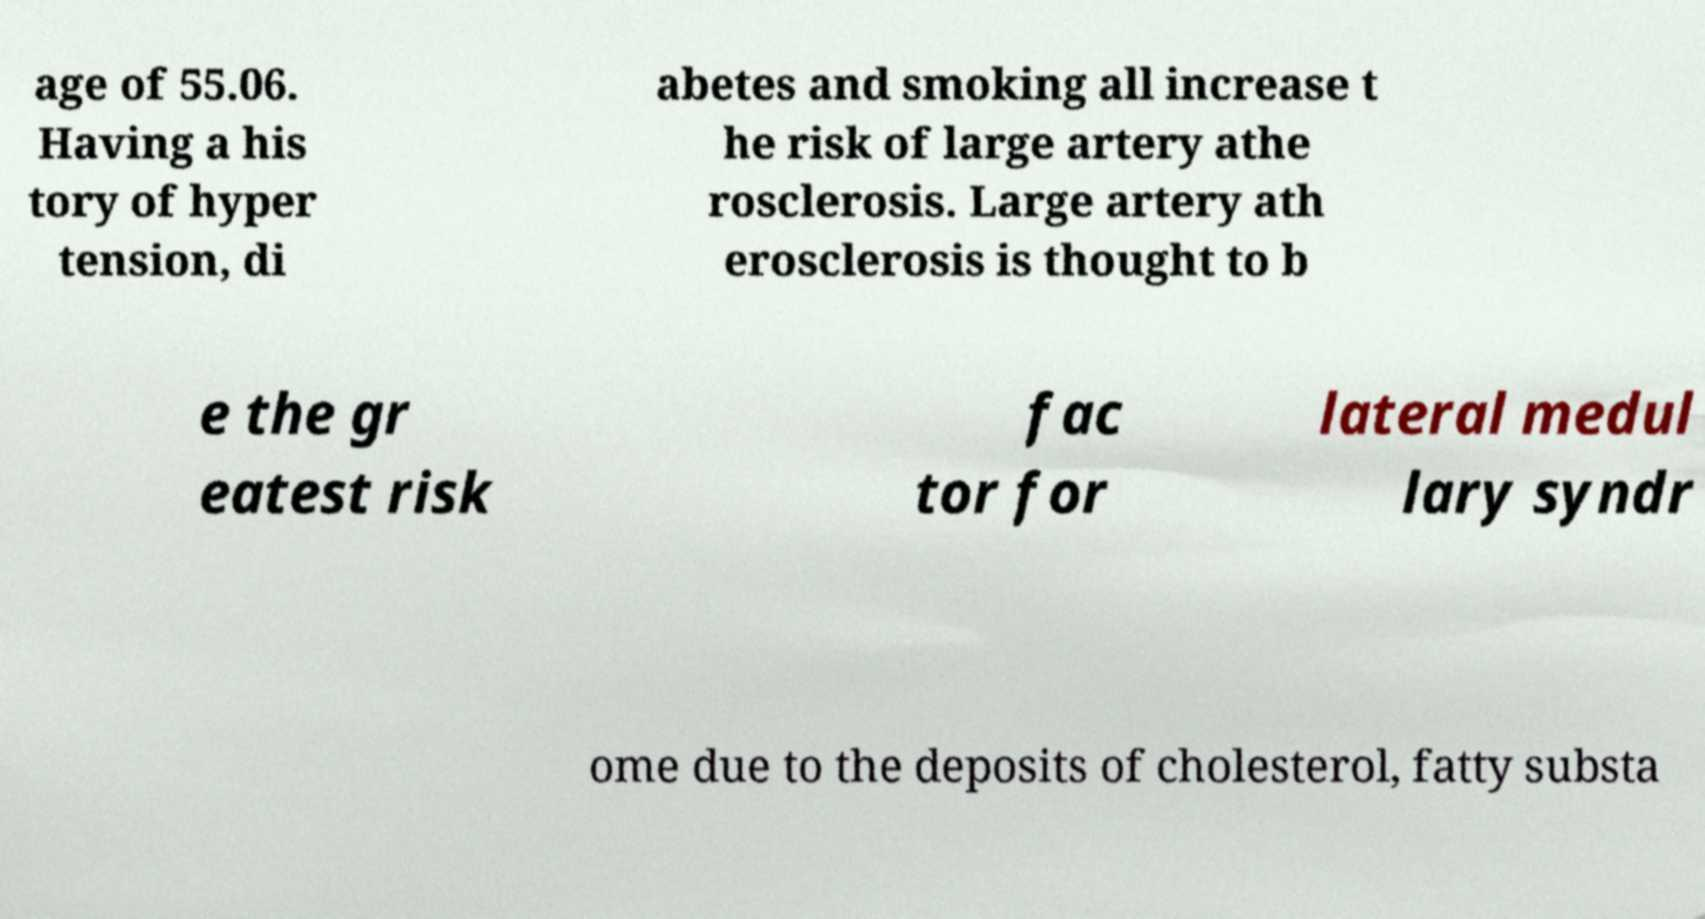Please read and relay the text visible in this image. What does it say? age of 55.06. Having a his tory of hyper tension, di abetes and smoking all increase t he risk of large artery athe rosclerosis. Large artery ath erosclerosis is thought to b e the gr eatest risk fac tor for lateral medul lary syndr ome due to the deposits of cholesterol, fatty substa 